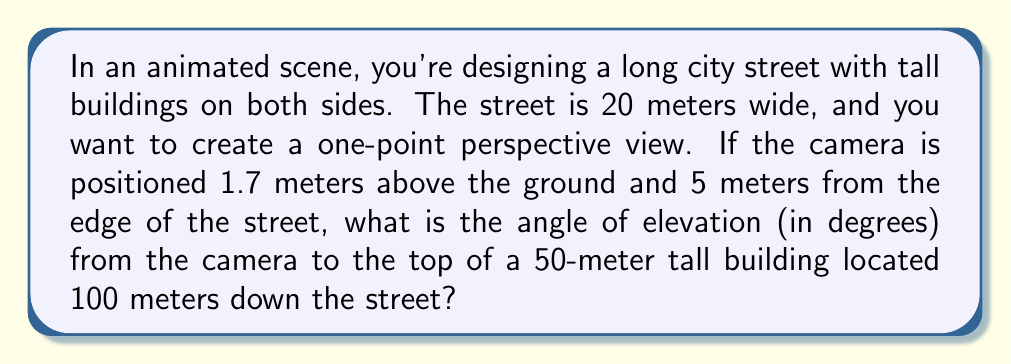What is the answer to this math problem? To solve this problem, we need to use trigonometry to calculate the angle of elevation. Let's break it down step-by-step:

1. First, let's visualize the scene:
   [asy]
   import geometry;
   
   size(200);
   
   pair A = (0,0);  // Camera position
   pair B = (100,0);  // Base of the building
   pair C = (100,50);  // Top of the building
   
   draw(A--B--C--A);
   
   label("Camera", A, SW);
   label("Building", B, S);
   label("50m", C, NE);
   label("100m", (50,0), S);
   label("θ", A, NE);
   [/asy]

2. We need to find the angle θ between the horizontal line and the line from the camera to the top of the building.

3. We can use the arctangent function to calculate this angle. We need the opposite and adjacent sides of the right triangle formed.

4. The adjacent side is the horizontal distance from the camera to the building:
   100 m (down the street) + 10 m (half the street width) - 5 m (camera distance from edge) = 105 m

5. The opposite side is the height difference:
   50 m (building height) - 1.7 m (camera height) = 48.3 m

6. Now we can calculate the angle:

   $$θ = \arctan(\frac{\text{opposite}}{\text{adjacent}}) = \arctan(\frac{48.3}{105})$$

7. Using a calculator or programming function:

   $$θ = \arctan(\frac{48.3}{105}) ≈ 24.69°$$

8. Round to two decimal places: 24.69°
Answer: 24.69° 